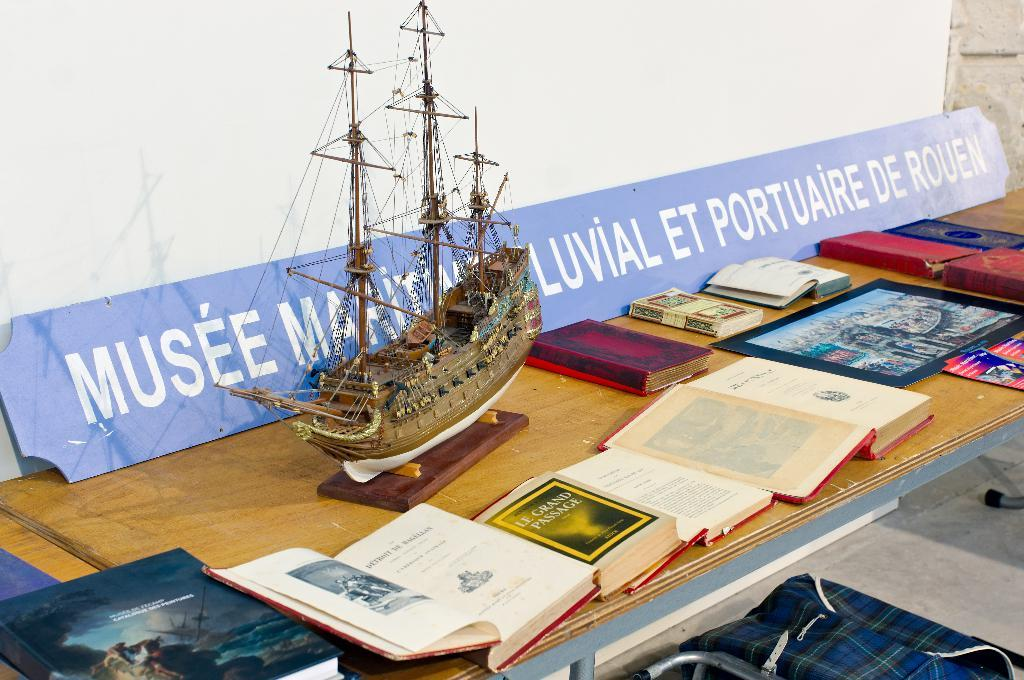<image>
Relay a brief, clear account of the picture shown. A boat and many books are on a table with a sign that says Musee on it. 